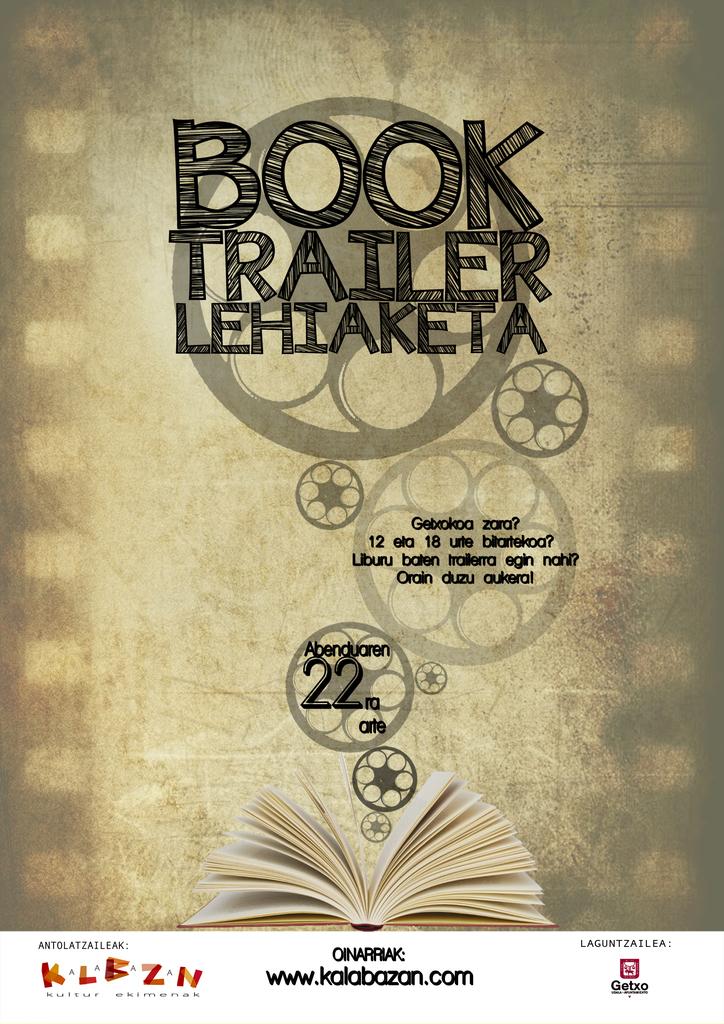What is the name of this book?
Your answer should be compact. Book trailer lehiaketa. What is the url to the website?
Ensure brevity in your answer.  Www.kalabazan.com. 